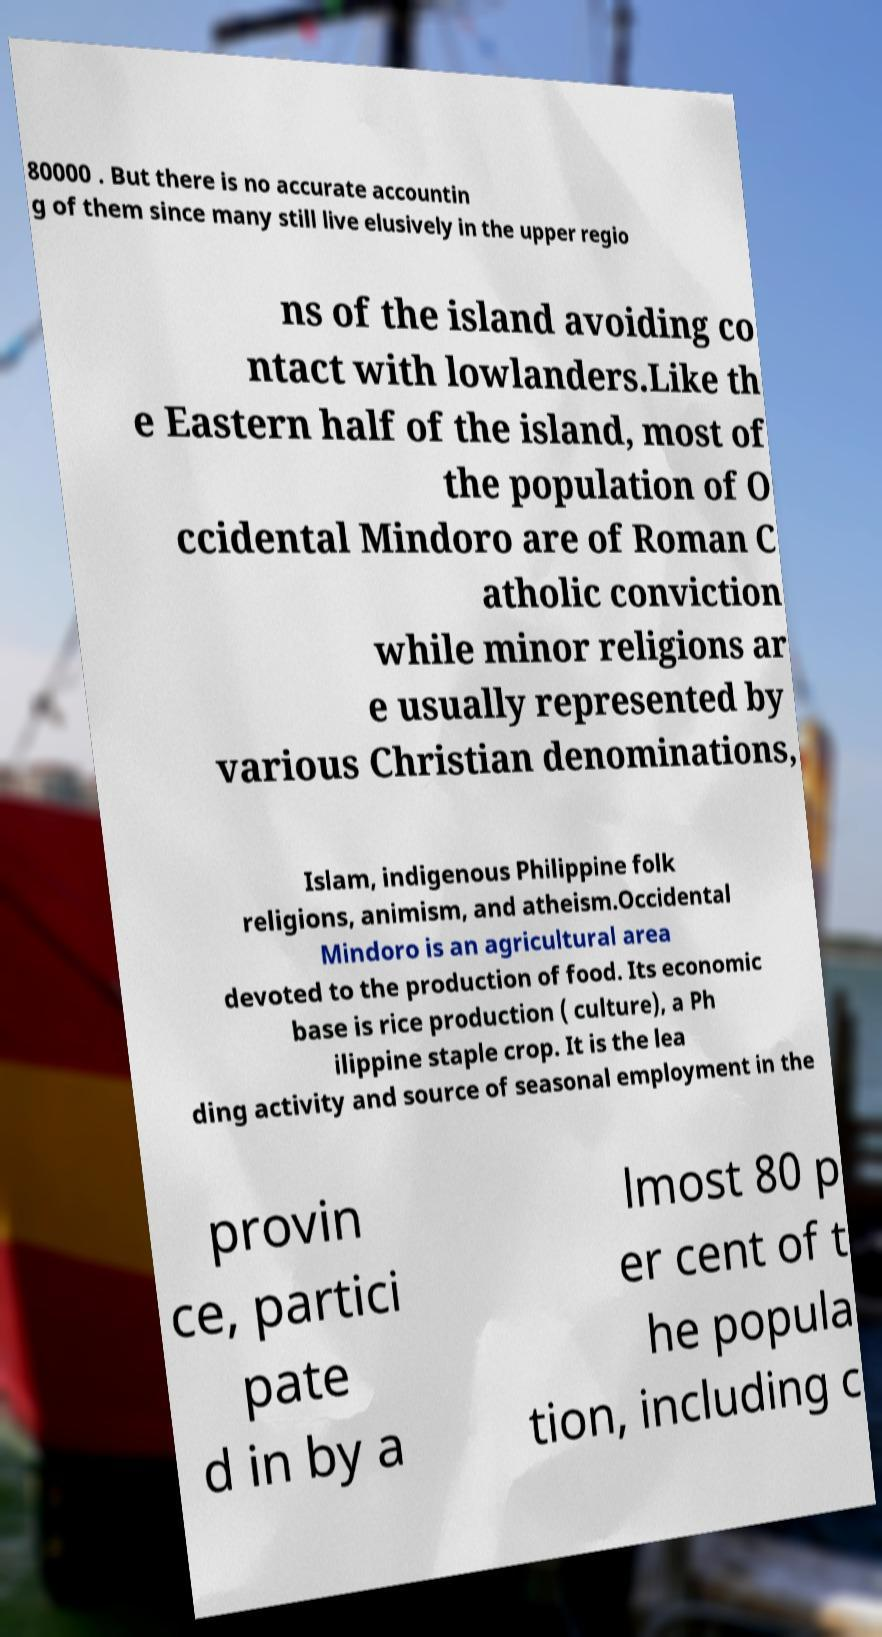Can you accurately transcribe the text from the provided image for me? 80000 . But there is no accurate accountin g of them since many still live elusively in the upper regio ns of the island avoiding co ntact with lowlanders.Like th e Eastern half of the island, most of the population of O ccidental Mindoro are of Roman C atholic conviction while minor religions ar e usually represented by various Christian denominations, Islam, indigenous Philippine folk religions, animism, and atheism.Occidental Mindoro is an agricultural area devoted to the production of food. Its economic base is rice production ( culture), a Ph ilippine staple crop. It is the lea ding activity and source of seasonal employment in the provin ce, partici pate d in by a lmost 80 p er cent of t he popula tion, including c 